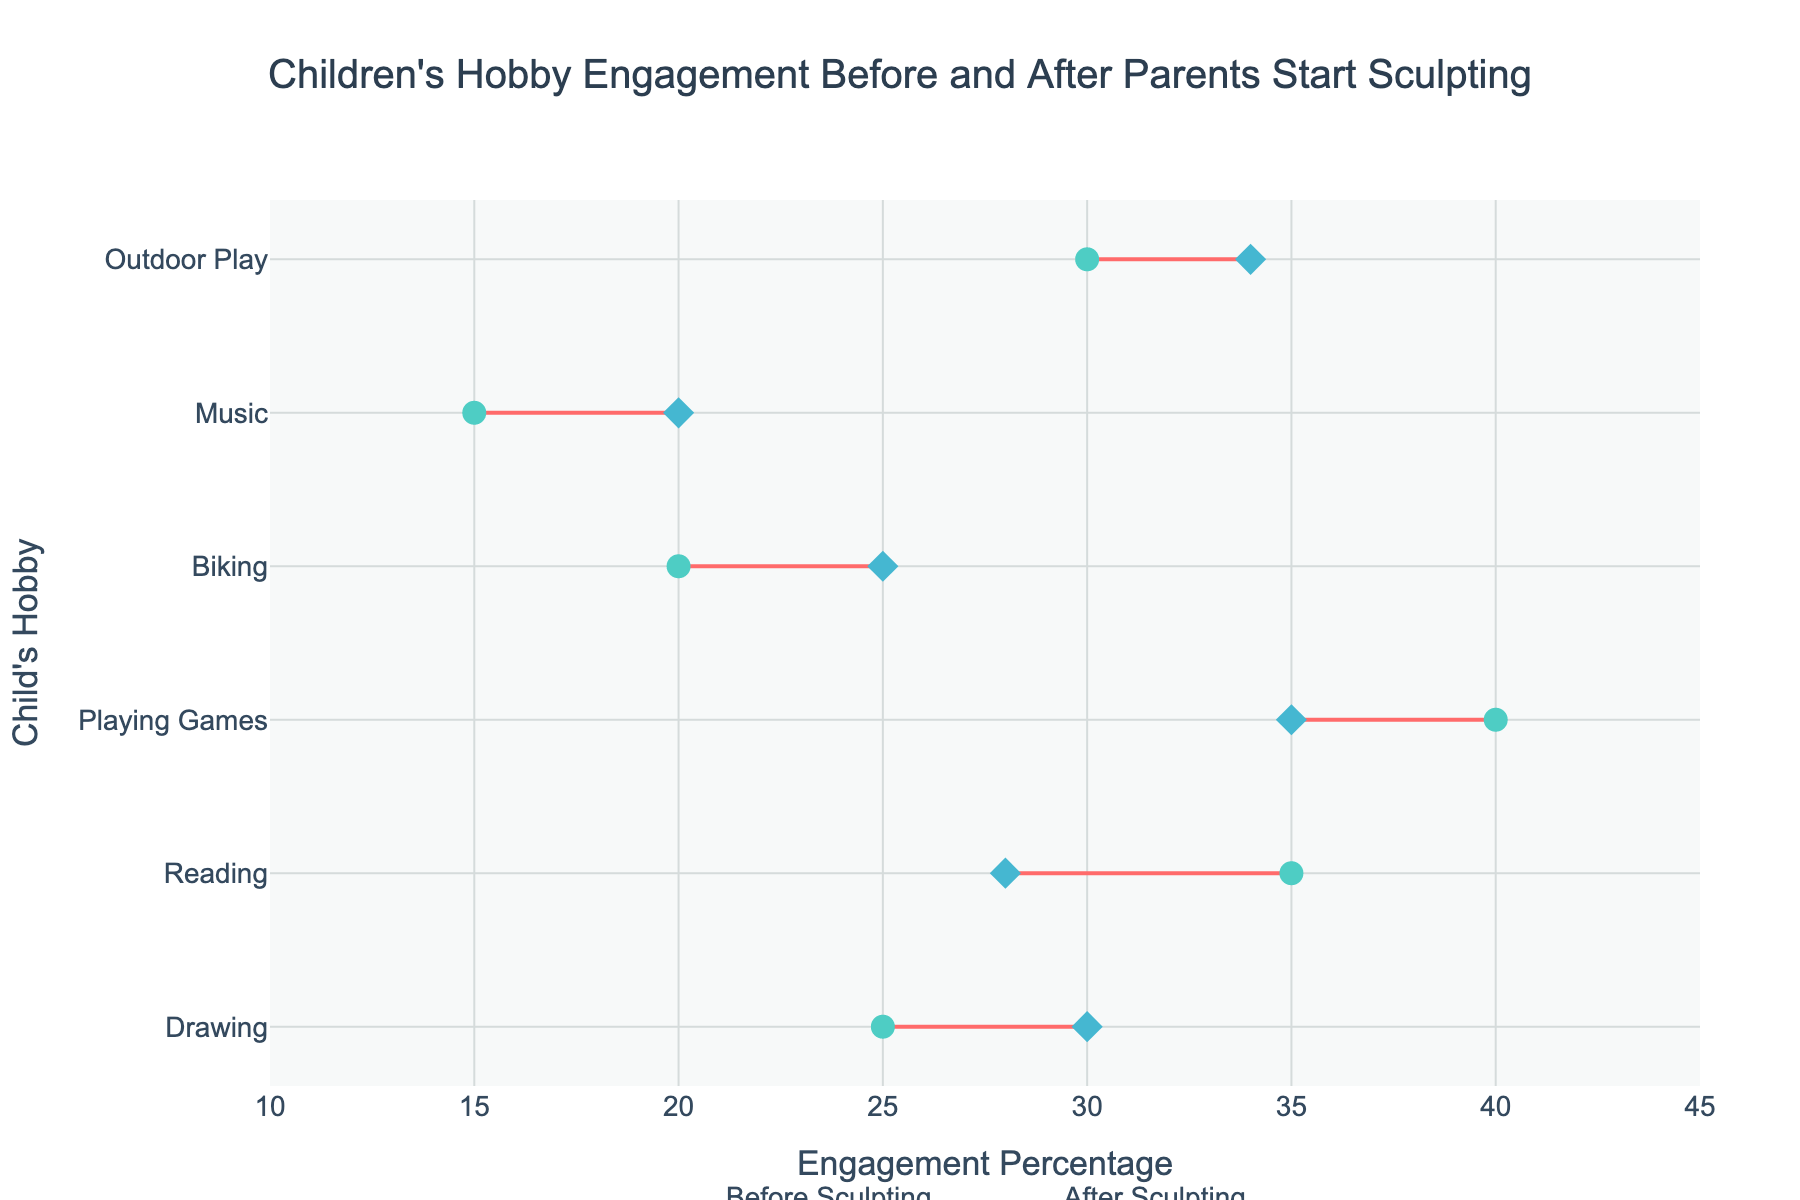what is the title of the plot? At the top of the plot, there is a text area displaying the title. The title is: "Children's Hobby Engagement Before and After Parents Start Sculpting".
Answer: Children's Hobby Engagement Before and After Parents Start Sculpting Which hobby saw the biggest increase in engagement percentage after parents started sculpting? Compare the "Before Engagement Percentage" and "After Engagement Percentage" for each hobby, then find the hobby with the highest increase. "Outdoor Play" increased from 30% to 34%, which is the highest among all hobbies, with a 4% increase.
Answer: Outdoor Play How did children's engagement in biking change after parents started sculpting? Locate the data points for "Biking." The "Before Engagement Percentage" is 20%, and the "After Engagement Percentage" is 25%. Subtract the former from the latter to find the change. The engagement increased by 5%.
Answer: Increased by 5% Which hobby had a decrease in engagement after parents started sculpting? Identify the hobbies where the "Before Engagement Percentage" is greater than the "After Engagement Percentage". "Reading" decreased from 35% to 28% and "Playing Games" decreased from 40% to 35%.
Answer: Reading and Playing Games What was the engagement percentage for music before parents started sculpting? Look for the data points related to "Music." The "Before Engagement Percentage" is listed as 15%.
Answer: 15% Which hobby experienced no change in engagement after parents started sculpting? Check each hobby and compare the "Before Engagement Percentage" and "After Engagement Percentage." If they are equal, the engagement percentage did not change. In this case, all hobbies experienced a change in engagement.
Answer: None Calculate the average engagement percentage after sculpting across all hobbies. Sum the "After Engagement Percentage" values (30 + 28 + 35 + 25 + 20 + 34) and divide by the number of hobbies (6). The total sum is 172, so the average is 172 / 6 ≈ 28.67.
Answer: 28.67 Which hobby had the highest engagement percentage before parents started sculpting? Compare the "Before Engagement Percentage" values for all hobbies. "Playing Games" has the highest before engagement percentage at 40%.
Answer: Playing Games Between Drawing and Reading, which hobby saw a larger absolute change in engagement percentage after parents started sculpting? Calculate the absolute change for each hobby: Drawing (30% - 25% = 5%) and Reading (35% - 28% = 7%). Reading had a larger absolute change.
Answer: Reading Does playing games have a higher or lower engagement after parents started sculpting? Compare the "Before Engagement Percentage" (40%) with the "After Engagement Percentage" (35%) for Playing Games. The engagement decreased, meaning it is lower.
Answer: Lower 